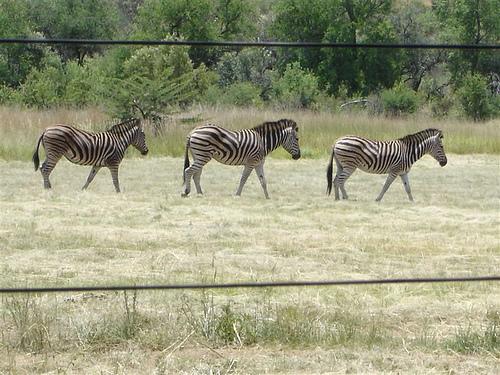Are all of the zebras facing the same direction?
Keep it brief. Yes. Where was this taken?
Keep it brief. Zoo. What type of animal is in the picture?
Answer briefly. Zebra. 